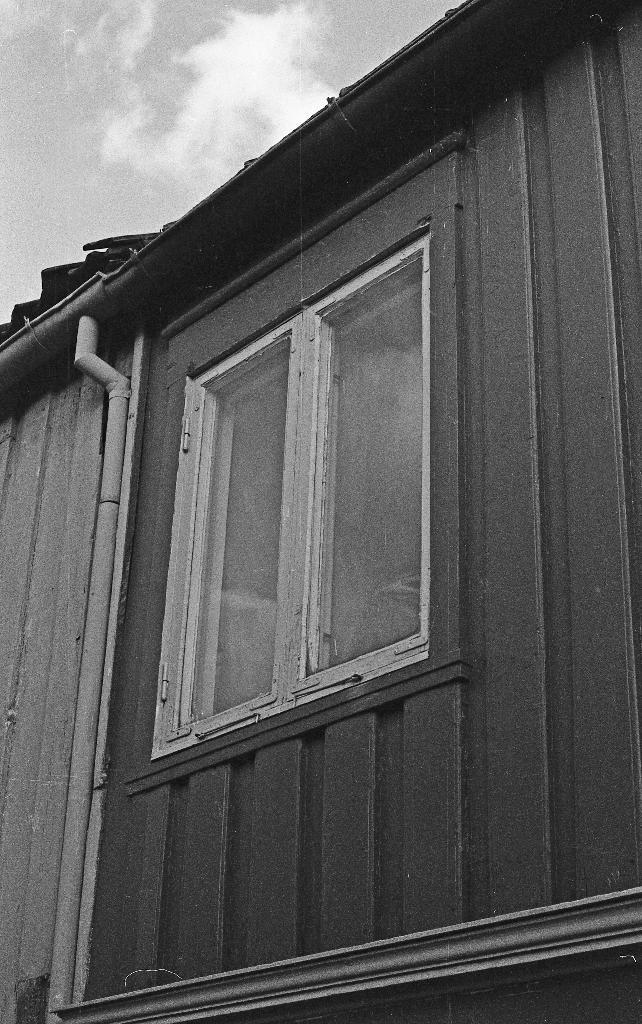What type of structure is visible in the image? There is a building in the image. Can you describe a specific part of the building? There is a window of the building in the image. What else can be seen in the image besides the building? There is a pipe in the image. What is visible in the background of the image? The sky is visible in the background of the image. How many deer can be seen grazing near the pipe in the image? There are no deer present in the image; it only features a building, a window, a pipe, and the sky. 